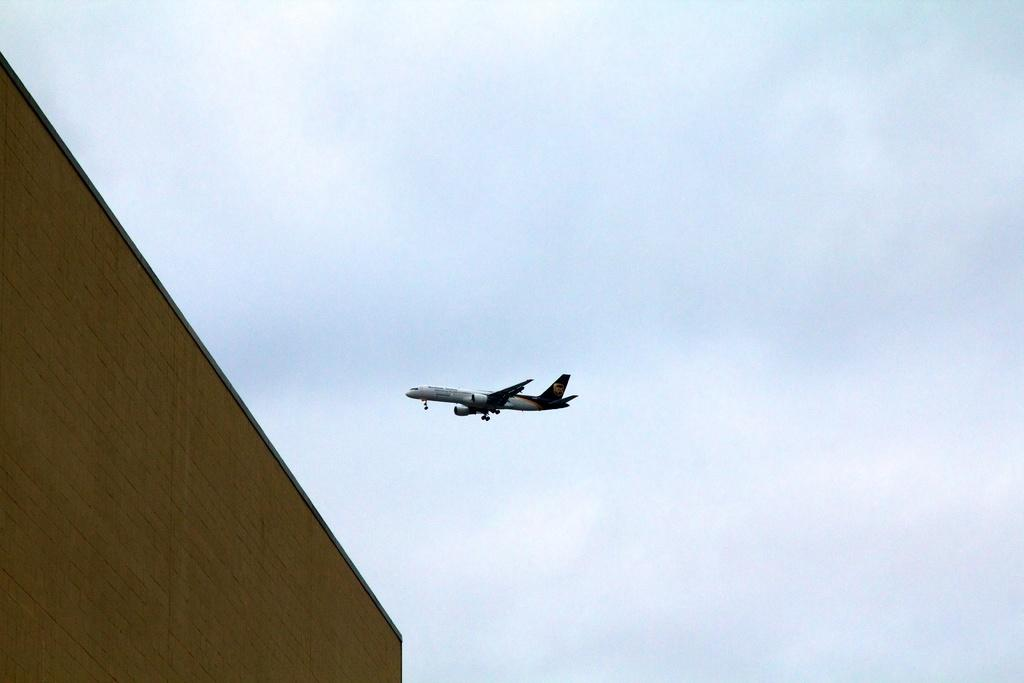What is the main subject in the center of the image? There is an aeroplane in the center of the image. What structure can be seen on the left side of the image? There is a building on the left side of the image. How many rabbits can be seen playing in the snow in the image? There are no rabbits or snow present in the image. What word is written on the building in the image? The provided facts do not mention any words written on the building, so it cannot be determined from the image. 